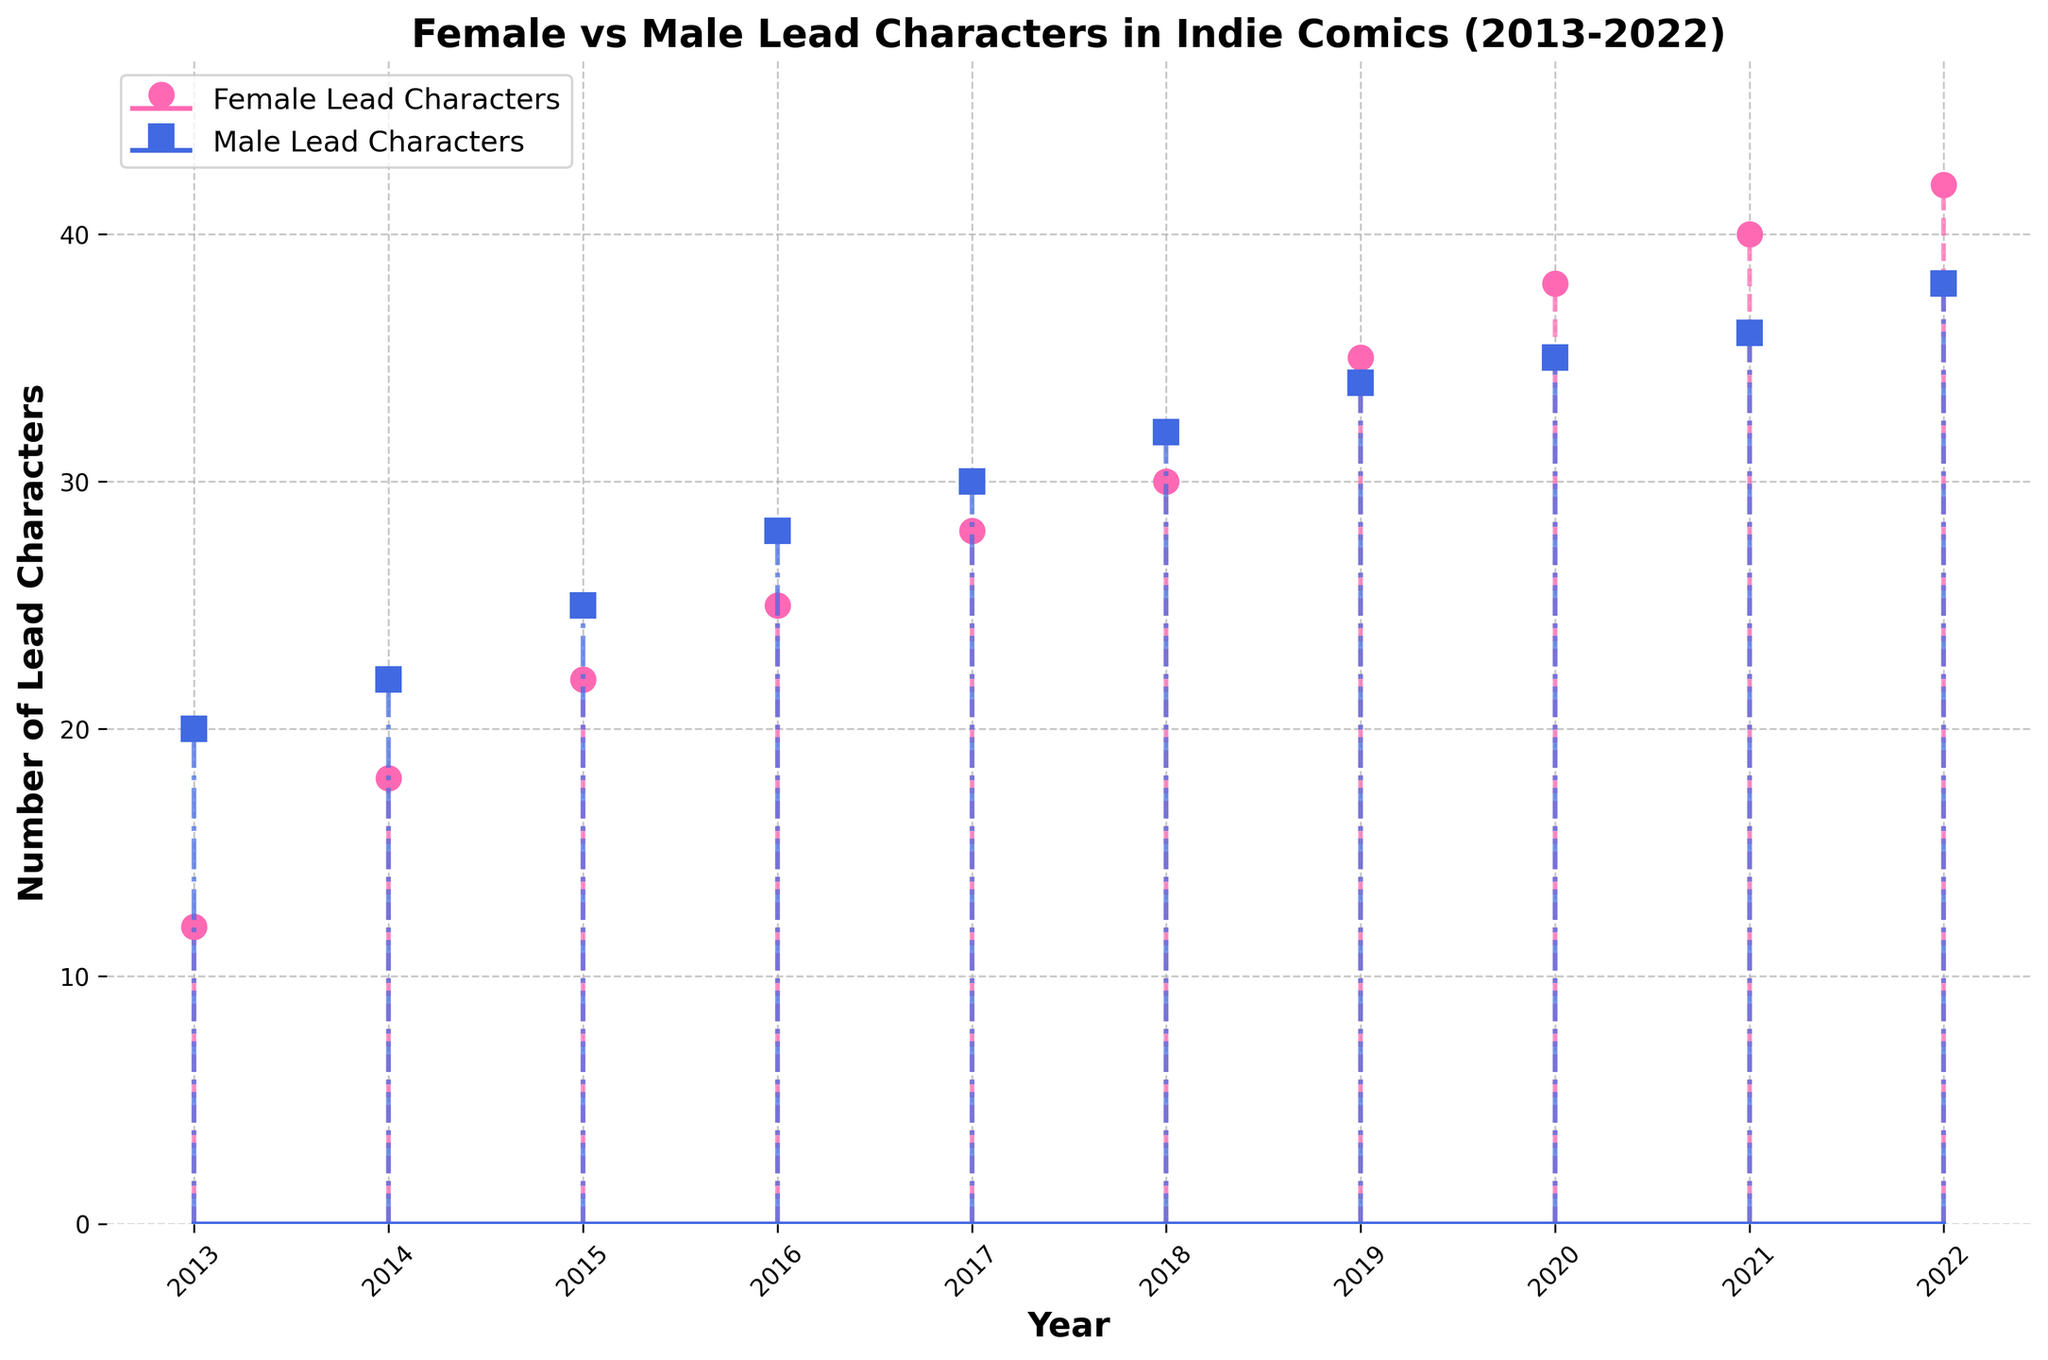How many data points are there in the stem plot? The x-axis represents the years from 2013 to 2022, which is 10 years. Each year has a corresponding point for both female and male lead characters.
Answer: 10 What is the color used for the markers representing male lead characters? The markers representing male lead characters are colored in a distinctive dark blue.
Answer: Dark blue Which year has the highest number of female lead characters? The highest point on the stem plot for female lead characters is in 2022, marked at 42.
Answer: 2022 How many female lead characters were there in 2018? Locate the point corresponding to the year 2018 and see where the marker intersects with the y-axis for female lead characters. The number is 30.
Answer: 30 What is the difference in the number of male lead characters between 2013 and 2022? In 2013, the number of male lead characters is 20, and in 2022, it is 38. The difference is 38 - 20 = 18.
Answer: 18 In which year did the female lead characters surpass the male lead characters? Compare the markers on the graph; in 2019, female lead characters (35) surpassed male lead characters (34).
Answer: 2019 How many more male lead characters were there than female lead characters in 2014? In 2014, male lead characters were 22, and female lead characters were 18. The difference is 22 - 18 = 4.
Answer: 4 What is the average number of female lead characters from 2019 to 2022? Sum the number of female lead characters from 2019 to 2022: 35, 38, 40, 42. (35 + 38 + 40 + 42) = 155. Divide by 4 to get the average: 155 / 4 = 38.75.
Answer: 38.75 When did the trend of increasing female lead characters begin? Starting from 2013, the number of female lead characters increases every year.
Answer: 2013 